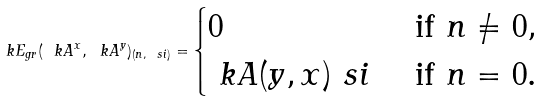<formula> <loc_0><loc_0><loc_500><loc_500>\ k E _ { g r } ( \ k A ^ { x } , \ k A ^ { y } ) _ { ( n , \ s i ) } = \begin{cases} 0 & \text { if } n \ne 0 , \\ \ k A ( y , x ) _ { \ } s i & \text { if } n = 0 . \end{cases}</formula> 